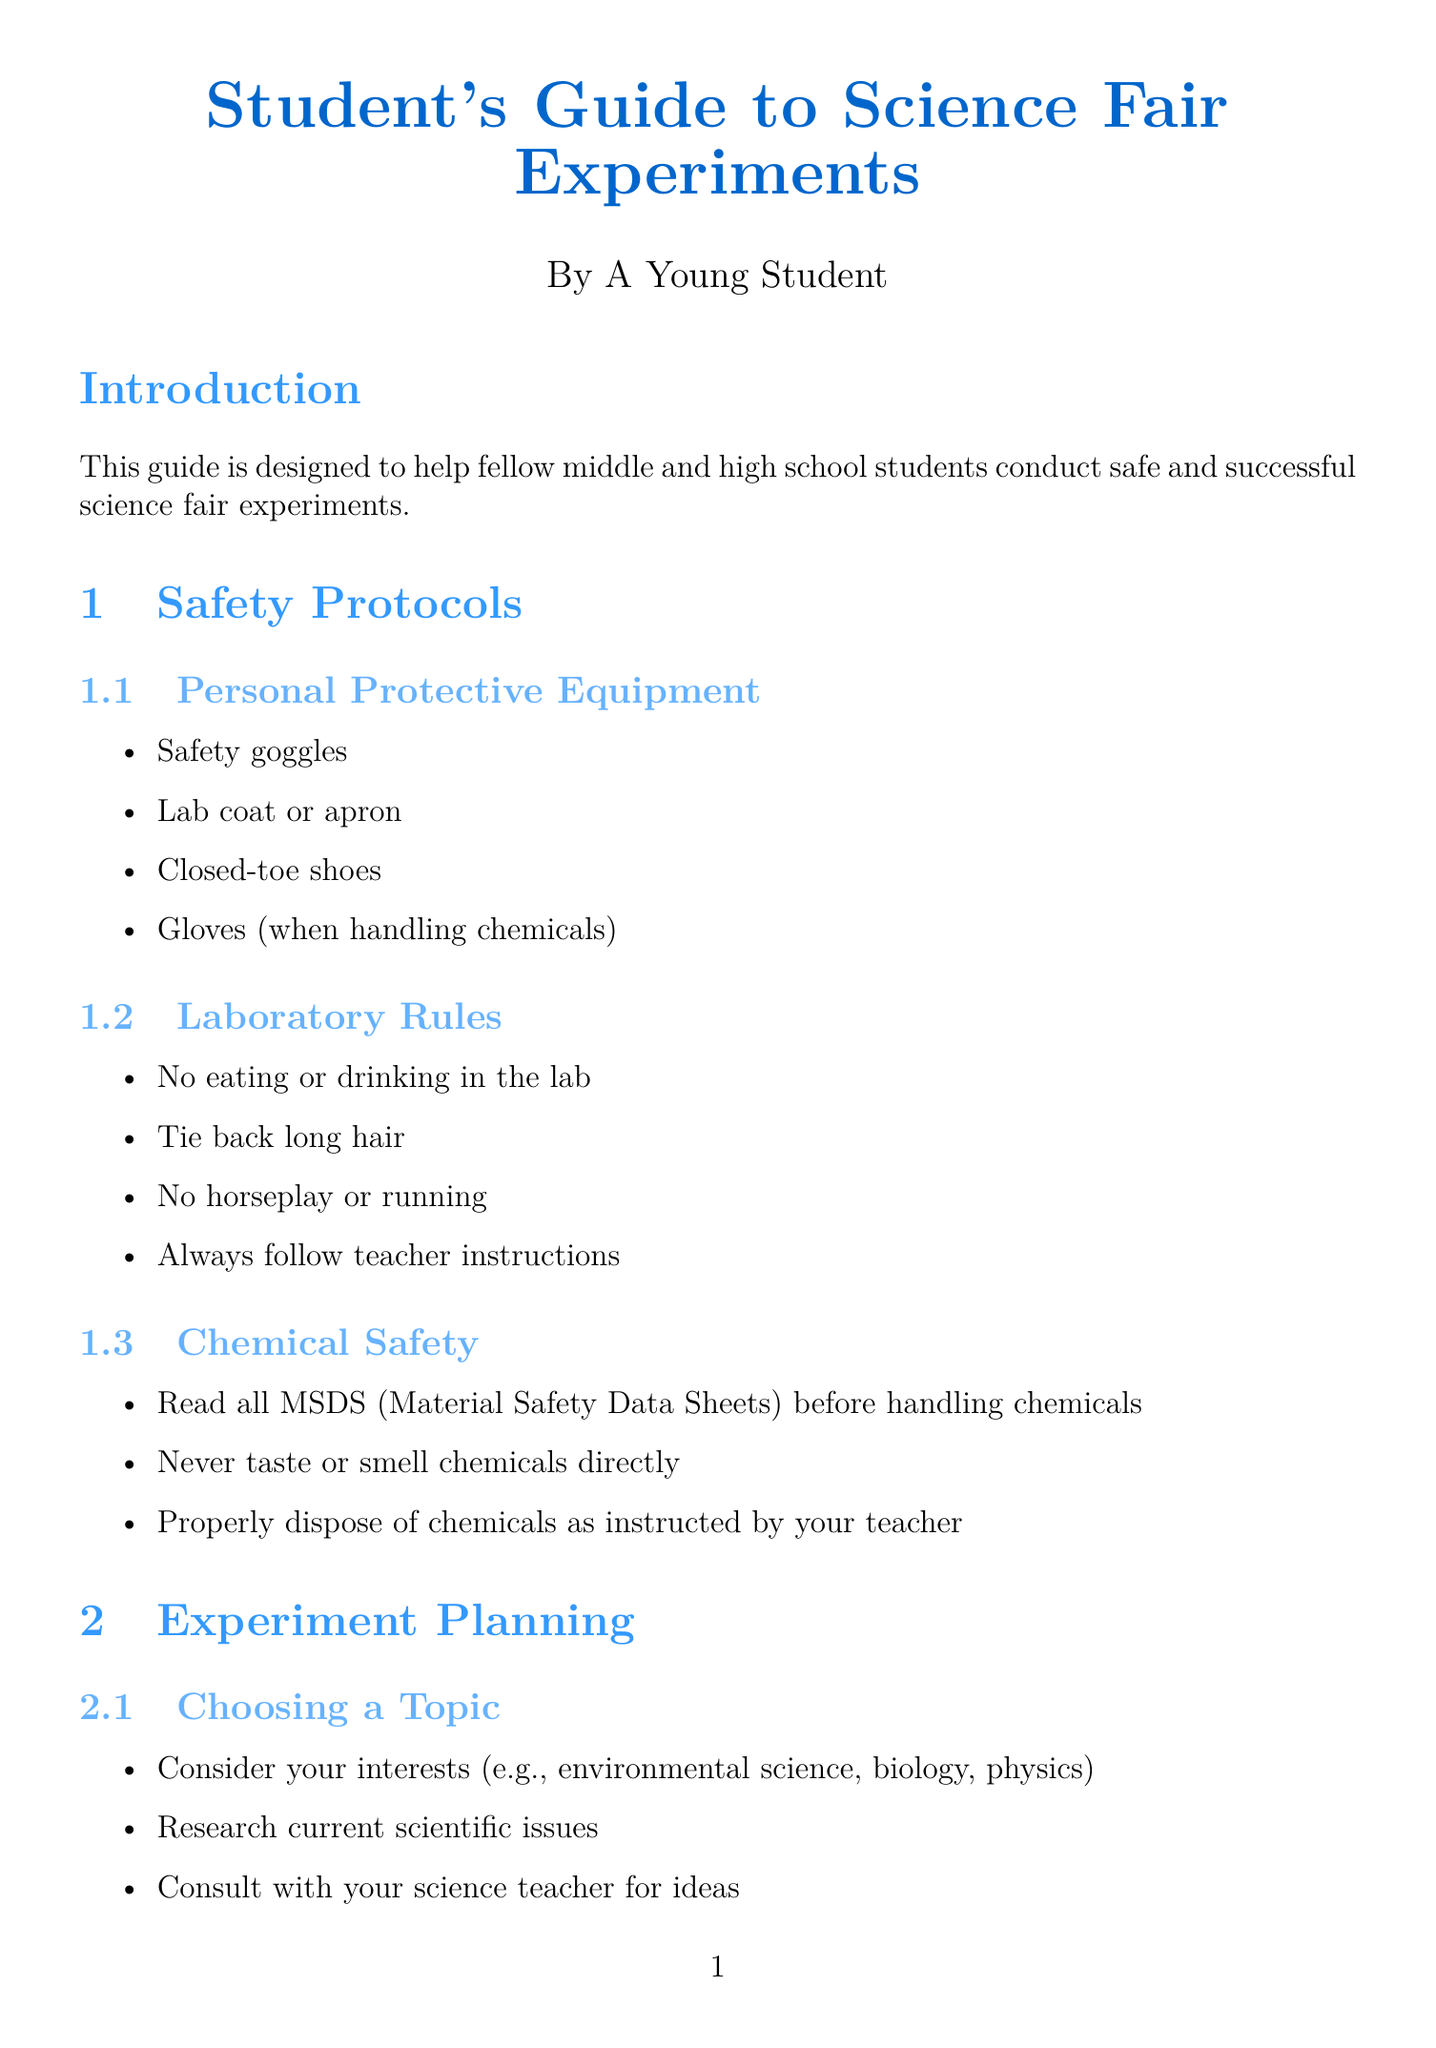What is the title of the document? The title is explicitly stated at the beginning of the document.
Answer: Student's Guide to Science Fair Experiments Who is the target audience for this guide? The document specifies the intended audience in the introduction section.
Answer: Middle and high school students What is an example of personal protective equipment mentioned? The document lists items in the safety protocols section.
Answer: Safety goggles What should you do before handling chemicals? The document provides specific safety procedures under chemical safety protocols.
Answer: Read all MSDS Which section is included in the display board? The document details the required sections for the display board in the presentation guidelines.
Answer: Abstract What is a key point to remember during the oral presentation? The document outlines essential points in the oral presentation guidelines.
Answer: Answer questions confidently Name one resource listed under websites. The document includes various resources, including online platforms in the resources section.
Answer: Science Buddies What is a common mistake to avoid when preparing for the science fair? The document lists mistakes to avoid in a dedicated section.
Answer: Procrastinating and rushing the experiment What is the purpose of this guide? The introduction states the overall aim of the document.
Answer: To help fellow students conduct safe and successful science fair experiments 